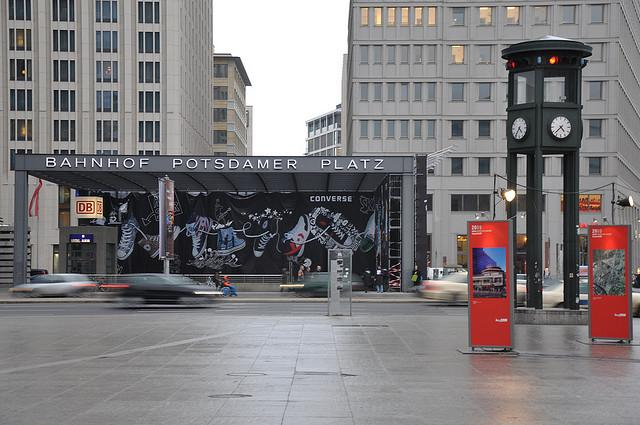One will come here if one wants to do what? buy shoes 